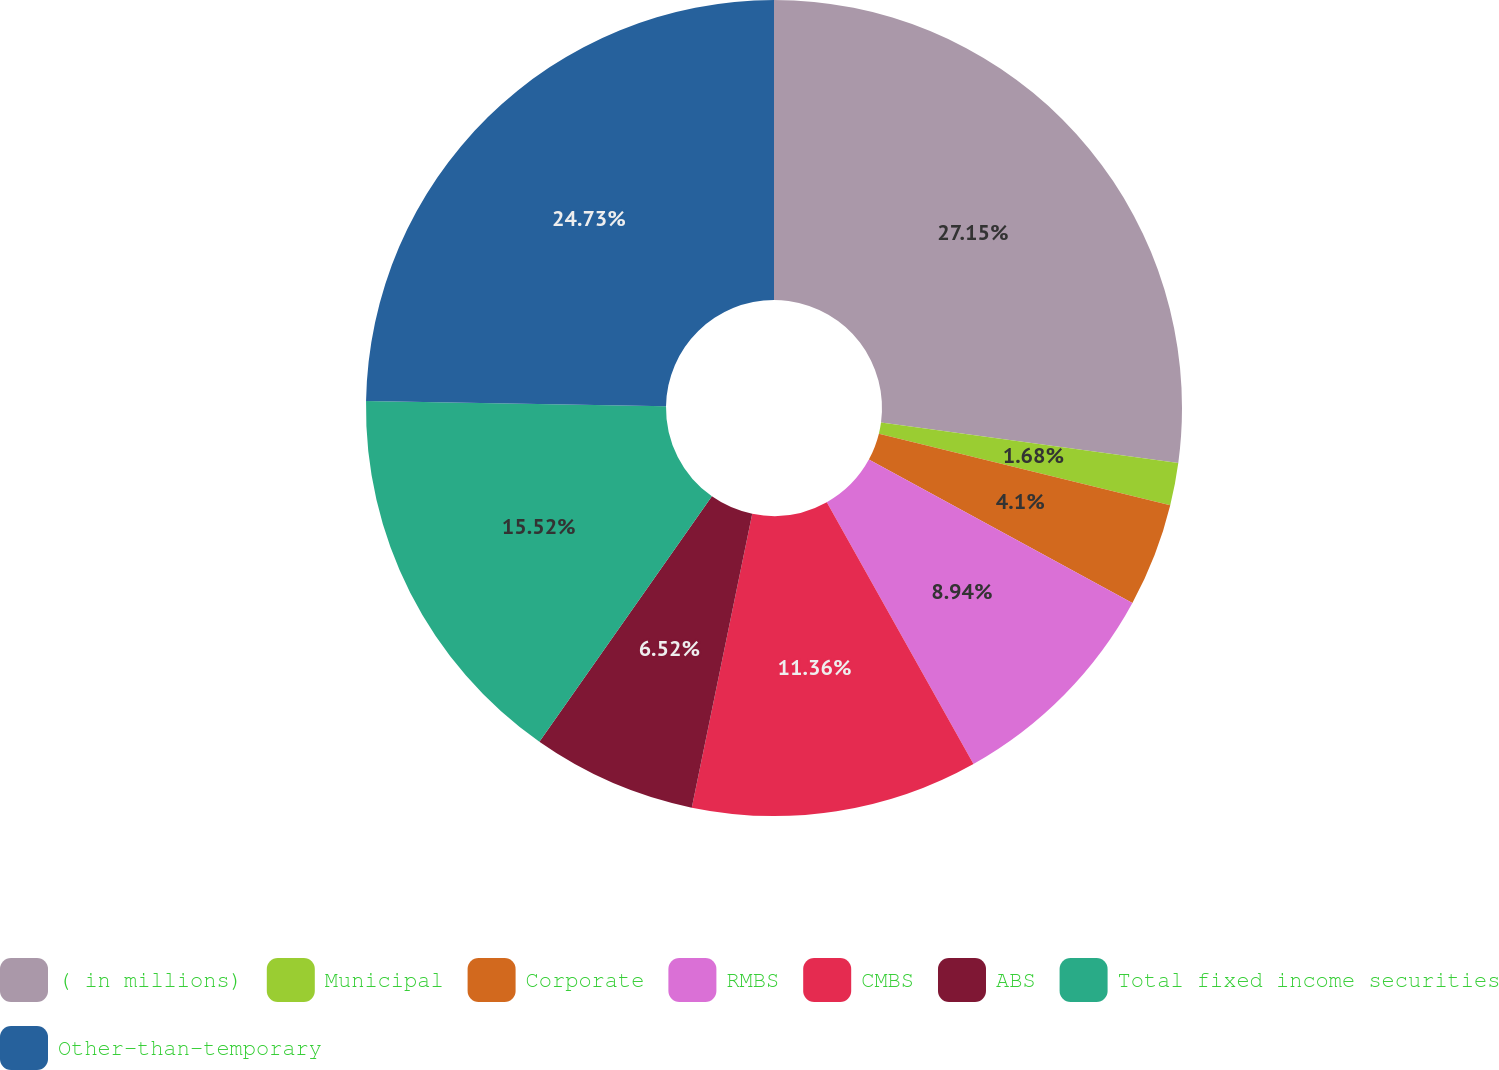Convert chart. <chart><loc_0><loc_0><loc_500><loc_500><pie_chart><fcel>( in millions)<fcel>Municipal<fcel>Corporate<fcel>RMBS<fcel>CMBS<fcel>ABS<fcel>Total fixed income securities<fcel>Other-than-temporary<nl><fcel>27.15%<fcel>1.68%<fcel>4.1%<fcel>8.94%<fcel>11.36%<fcel>6.52%<fcel>15.52%<fcel>24.73%<nl></chart> 